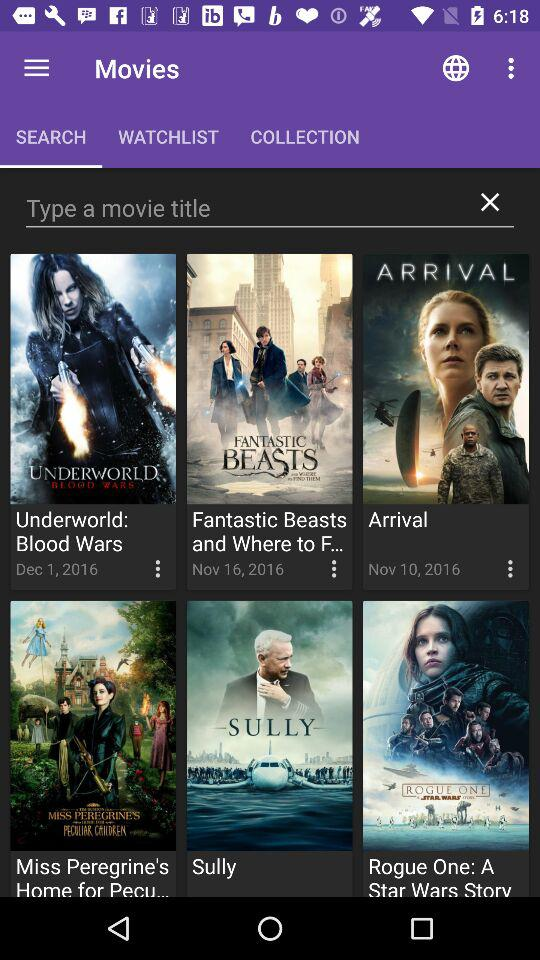What is the real date of the movie's arrival?
When the provided information is insufficient, respond with <no answer>. <no answer> 